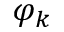<formula> <loc_0><loc_0><loc_500><loc_500>\varphi _ { k }</formula> 